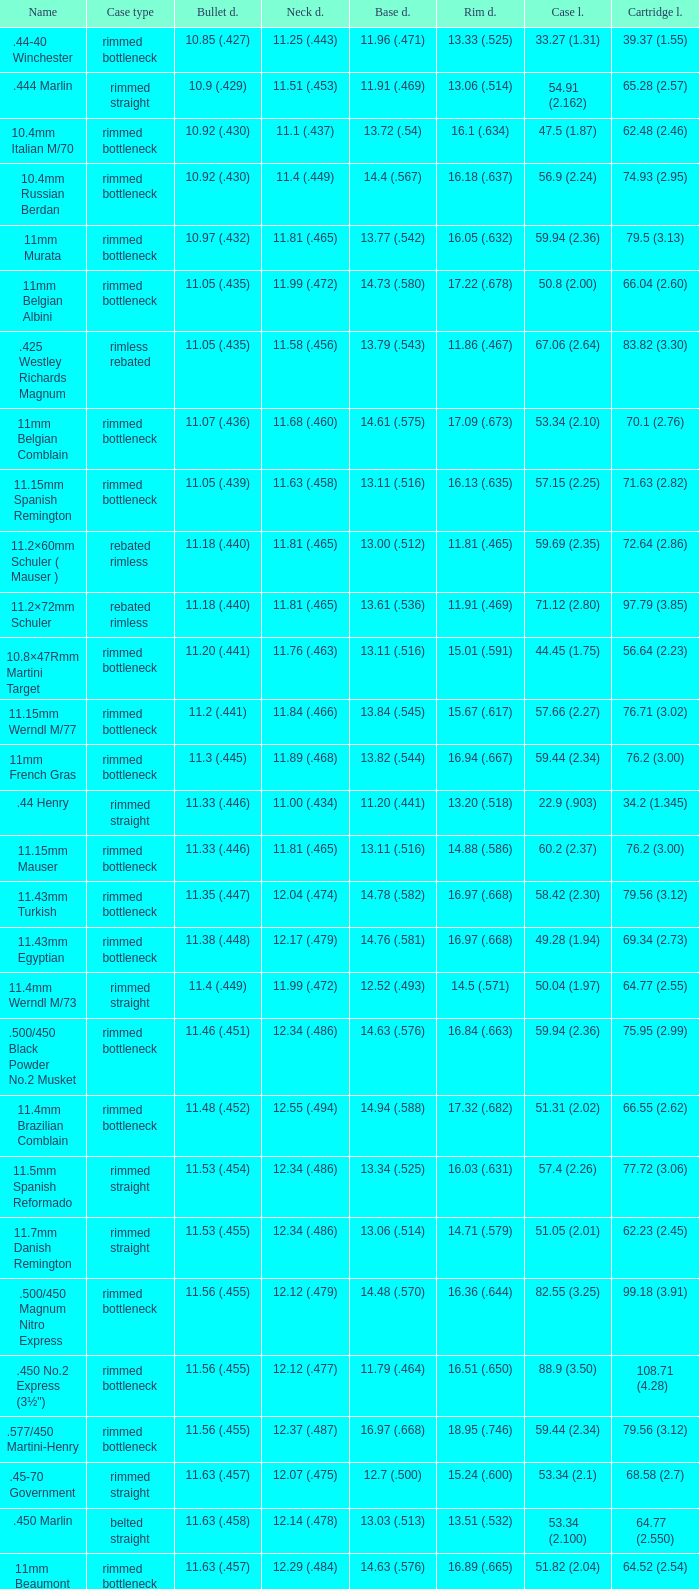Which Case length has a Rim diameter of 13.20 (.518)? 22.9 (.903). 